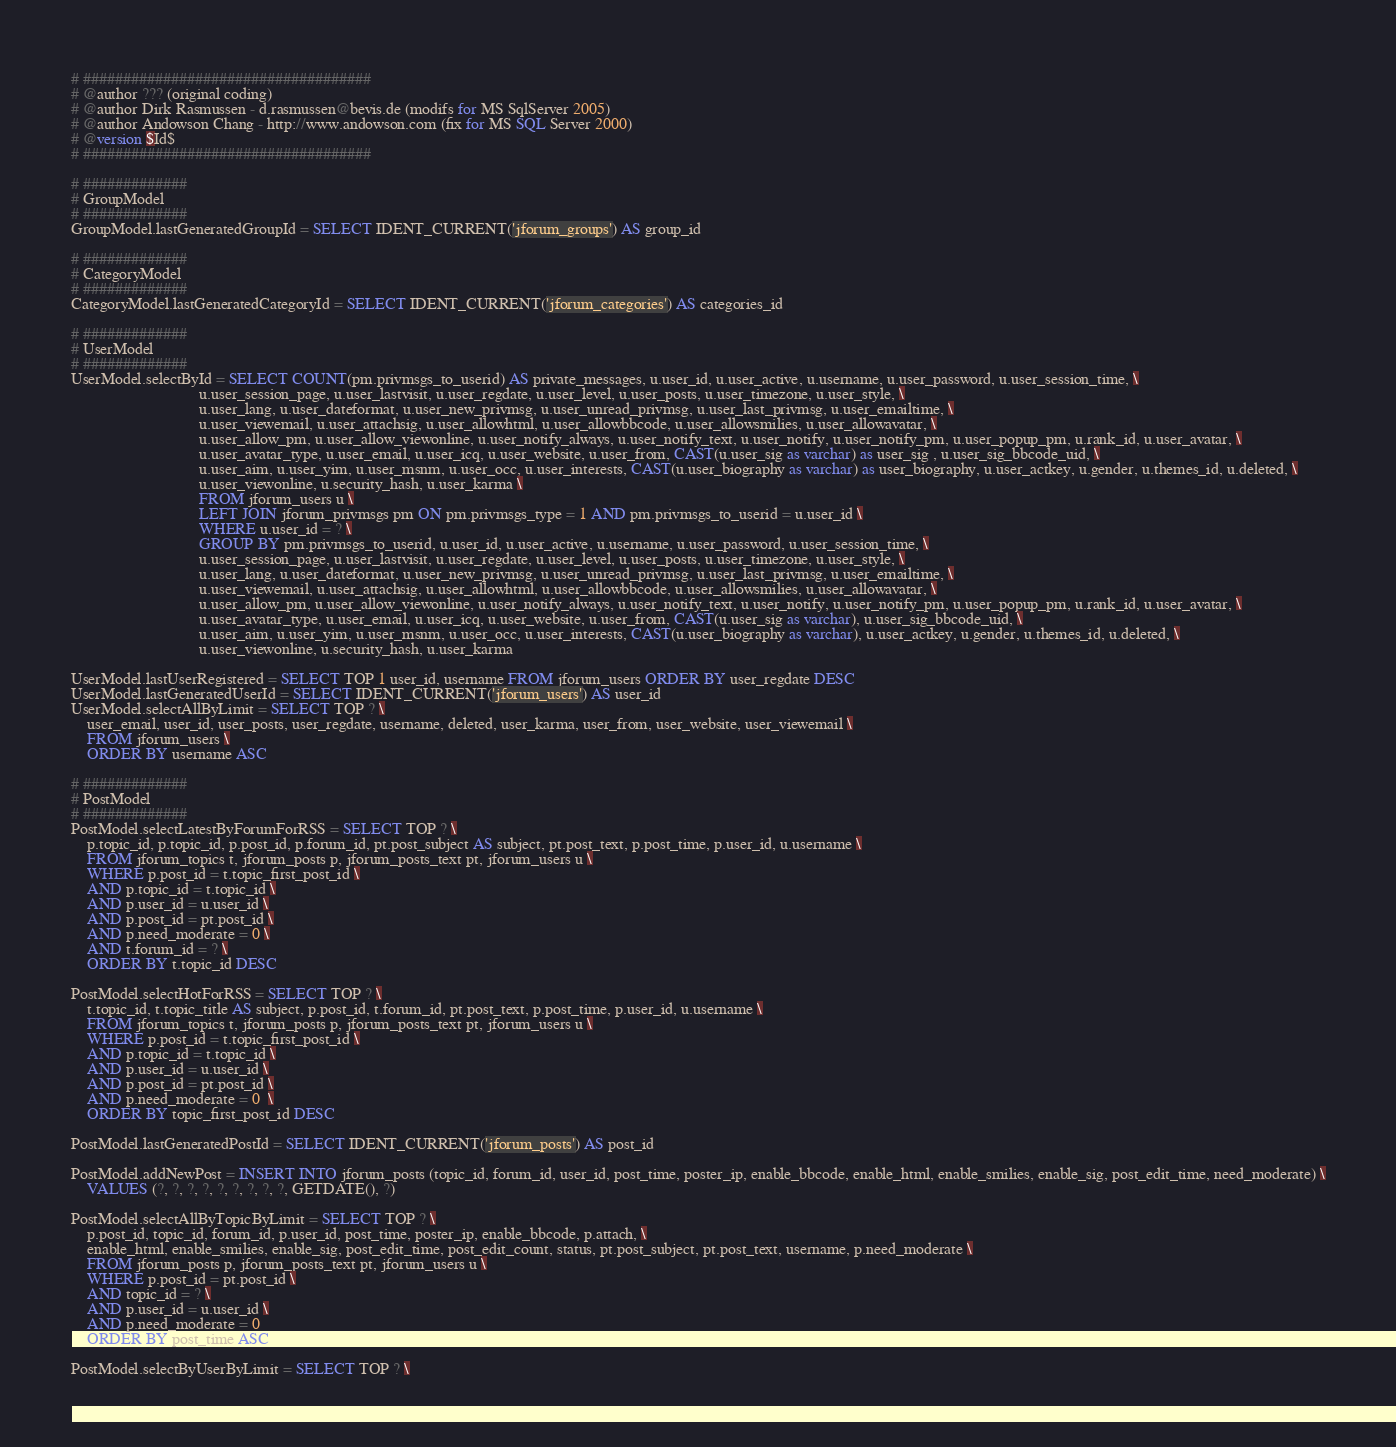Convert code to text. <code><loc_0><loc_0><loc_500><loc_500><_SQL_># ####################################
# @author ??? (original coding)
# @author Dirk Rasmussen - d.rasmussen@bevis.de (modifs for MS SqlServer 2005)
# @author Andowson Chang - http://www.andowson.com (fix for MS SQL Server 2000)
# @version $Id$
# ####################################

# #############
# GroupModel
# #############
GroupModel.lastGeneratedGroupId = SELECT IDENT_CURRENT('jforum_groups') AS group_id

# #############
# CategoryModel
# #############
CategoryModel.lastGeneratedCategoryId = SELECT IDENT_CURRENT('jforum_categories') AS categories_id 

# #############
# UserModel
# #############
UserModel.selectById = SELECT COUNT(pm.privmsgs_to_userid) AS private_messages, u.user_id, u.user_active, u.username, u.user_password, u.user_session_time, \
								u.user_session_page, u.user_lastvisit, u.user_regdate, u.user_level, u.user_posts, u.user_timezone, u.user_style, \
								u.user_lang, u.user_dateformat, u.user_new_privmsg, u.user_unread_privmsg, u.user_last_privmsg, u.user_emailtime, \
								u.user_viewemail, u.user_attachsig, u.user_allowhtml, u.user_allowbbcode, u.user_allowsmilies, u.user_allowavatar, \
								u.user_allow_pm, u.user_allow_viewonline, u.user_notify_always, u.user_notify_text, u.user_notify, u.user_notify_pm, u.user_popup_pm, u.rank_id, u.user_avatar, \
								u.user_avatar_type, u.user_email, u.user_icq, u.user_website, u.user_from, CAST(u.user_sig as varchar) as user_sig , u.user_sig_bbcode_uid, \
								u.user_aim, u.user_yim, u.user_msnm, u.user_occ, u.user_interests, CAST(u.user_biography as varchar) as user_biography, u.user_actkey, u.gender, u.themes_id, u.deleted, \
								u.user_viewonline, u.security_hash, u.user_karma \
								FROM jforum_users u \
								LEFT JOIN jforum_privmsgs pm ON pm.privmsgs_type = 1 AND pm.privmsgs_to_userid = u.user_id \
								WHERE u.user_id = ? \
								GROUP BY pm.privmsgs_to_userid, u.user_id, u.user_active, u.username, u.user_password, u.user_session_time, \
								u.user_session_page, u.user_lastvisit, u.user_regdate, u.user_level, u.user_posts, u.user_timezone, u.user_style, \
								u.user_lang, u.user_dateformat, u.user_new_privmsg, u.user_unread_privmsg, u.user_last_privmsg, u.user_emailtime, \
								u.user_viewemail, u.user_attachsig, u.user_allowhtml, u.user_allowbbcode, u.user_allowsmilies, u.user_allowavatar, \
								u.user_allow_pm, u.user_allow_viewonline, u.user_notify_always, u.user_notify_text, u.user_notify, u.user_notify_pm, u.user_popup_pm, u.rank_id, u.user_avatar, \
								u.user_avatar_type, u.user_email, u.user_icq, u.user_website, u.user_from, CAST(u.user_sig as varchar), u.user_sig_bbcode_uid, \
								u.user_aim, u.user_yim, u.user_msnm, u.user_occ, u.user_interests, CAST(u.user_biography as varchar), u.user_actkey, u.gender, u.themes_id, u.deleted, \
								u.user_viewonline, u.security_hash, u.user_karma
								
UserModel.lastUserRegistered = SELECT TOP 1 user_id, username FROM jforum_users ORDER BY user_regdate DESC
UserModel.lastGeneratedUserId = SELECT IDENT_CURRENT('jforum_users') AS user_id
UserModel.selectAllByLimit = SELECT TOP ? \
	user_email, user_id, user_posts, user_regdate, username, deleted, user_karma, user_from, user_website, user_viewemail \
	FROM jforum_users \
	ORDER BY username ASC

# #############
# PostModel
# #############
PostModel.selectLatestByForumForRSS = SELECT TOP ? \
    p.topic_id, p.topic_id, p.post_id, p.forum_id, pt.post_subject AS subject, pt.post_text, p.post_time, p.user_id, u.username \
	FROM jforum_topics t, jforum_posts p, jforum_posts_text pt, jforum_users u \
	WHERE p.post_id = t.topic_first_post_id \
	AND p.topic_id = t.topic_id \
	AND p.user_id = u.user_id \
	AND p.post_id = pt.post_id \
	AND p.need_moderate = 0 \
	AND t.forum_id = ? \
	ORDER BY t.topic_id DESC
	
PostModel.selectHotForRSS = SELECT TOP ? \
    t.topic_id, t.topic_title AS subject, p.post_id, t.forum_id, pt.post_text, p.post_time, p.user_id, u.username \
	FROM jforum_topics t, jforum_posts p, jforum_posts_text pt, jforum_users u \
	WHERE p.post_id = t.topic_first_post_id \
	AND p.topic_id = t.topic_id \
	AND p.user_id = u.user_id \
	AND p.post_id = pt.post_id \
	AND p.need_moderate = 0  \
	ORDER BY topic_first_post_id DESC

PostModel.lastGeneratedPostId = SELECT IDENT_CURRENT('jforum_posts') AS post_id

PostModel.addNewPost = INSERT INTO jforum_posts (topic_id, forum_id, user_id, post_time, poster_ip, enable_bbcode, enable_html, enable_smilies, enable_sig, post_edit_time, need_moderate) \
	VALUES (?, ?, ?, ?, ?, ?, ?, ?, ?, GETDATE(), ?)

PostModel.selectAllByTopicByLimit = SELECT TOP ? \
	p.post_id, topic_id, forum_id, p.user_id, post_time, poster_ip, enable_bbcode, p.attach, \
	enable_html, enable_smilies, enable_sig, post_edit_time, post_edit_count, status, pt.post_subject, pt.post_text, username, p.need_moderate \
	FROM jforum_posts p, jforum_posts_text pt, jforum_users u \
	WHERE p.post_id = pt.post_id \
	AND topic_id = ? \
	AND p.user_id = u.user_id \
	AND p.need_moderate = 0 
	ORDER BY post_time ASC

PostModel.selectByUserByLimit = SELECT TOP ? \</code> 